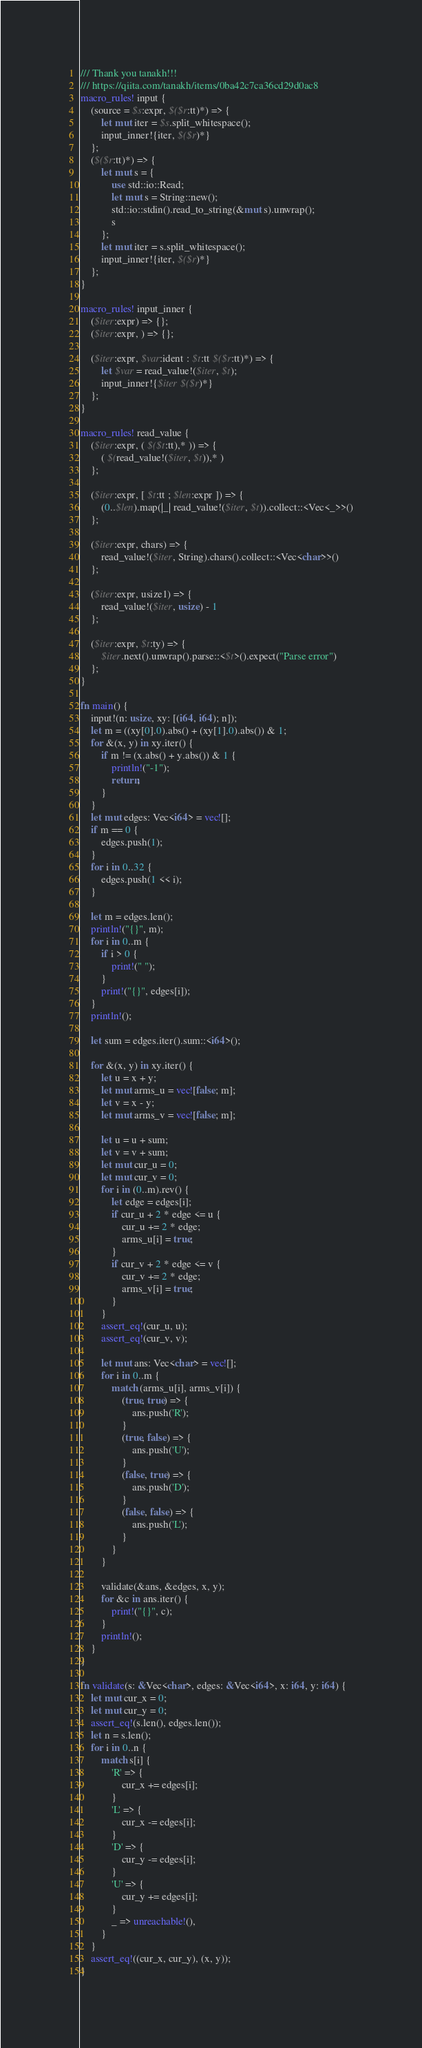<code> <loc_0><loc_0><loc_500><loc_500><_Rust_>/// Thank you tanakh!!!
/// https://qiita.com/tanakh/items/0ba42c7ca36cd29d0ac8
macro_rules! input {
    (source = $s:expr, $($r:tt)*) => {
        let mut iter = $s.split_whitespace();
        input_inner!{iter, $($r)*}
    };
    ($($r:tt)*) => {
        let mut s = {
            use std::io::Read;
            let mut s = String::new();
            std::io::stdin().read_to_string(&mut s).unwrap();
            s
        };
        let mut iter = s.split_whitespace();
        input_inner!{iter, $($r)*}
    };
}

macro_rules! input_inner {
    ($iter:expr) => {};
    ($iter:expr, ) => {};

    ($iter:expr, $var:ident : $t:tt $($r:tt)*) => {
        let $var = read_value!($iter, $t);
        input_inner!{$iter $($r)*}
    };
}

macro_rules! read_value {
    ($iter:expr, ( $($t:tt),* )) => {
        ( $(read_value!($iter, $t)),* )
    };

    ($iter:expr, [ $t:tt ; $len:expr ]) => {
        (0..$len).map(|_| read_value!($iter, $t)).collect::<Vec<_>>()
    };

    ($iter:expr, chars) => {
        read_value!($iter, String).chars().collect::<Vec<char>>()
    };

    ($iter:expr, usize1) => {
        read_value!($iter, usize) - 1
    };

    ($iter:expr, $t:ty) => {
        $iter.next().unwrap().parse::<$t>().expect("Parse error")
    };
}

fn main() {
    input!(n: usize, xy: [(i64, i64); n]);
    let m = ((xy[0].0).abs() + (xy[1].0).abs()) & 1;
    for &(x, y) in xy.iter() {
        if m != (x.abs() + y.abs()) & 1 {
            println!("-1");
            return;
        }
    }
    let mut edges: Vec<i64> = vec![];
    if m == 0 {
        edges.push(1);
    }
    for i in 0..32 {
        edges.push(1 << i);
    }

    let m = edges.len();
    println!("{}", m);
    for i in 0..m {
        if i > 0 {
            print!(" ");
        }
        print!("{}", edges[i]);
    }
    println!();

    let sum = edges.iter().sum::<i64>();

    for &(x, y) in xy.iter() {
        let u = x + y;
        let mut arms_u = vec![false; m];
        let v = x - y;
        let mut arms_v = vec![false; m];

        let u = u + sum;
        let v = v + sum;
        let mut cur_u = 0;
        let mut cur_v = 0;
        for i in (0..m).rev() {
            let edge = edges[i];
            if cur_u + 2 * edge <= u {
                cur_u += 2 * edge;
                arms_u[i] = true;
            }
            if cur_v + 2 * edge <= v {
                cur_v += 2 * edge;
                arms_v[i] = true;
            }
        }
        assert_eq!(cur_u, u);
        assert_eq!(cur_v, v);

        let mut ans: Vec<char> = vec![];
        for i in 0..m {
            match (arms_u[i], arms_v[i]) {
                (true, true) => {
                    ans.push('R');
                }
                (true, false) => {
                    ans.push('U');
                }
                (false, true) => {
                    ans.push('D');
                }
                (false, false) => {
                    ans.push('L');
                }
            }
        }

        validate(&ans, &edges, x, y);
        for &c in ans.iter() {
            print!("{}", c);
        }
        println!();
    }
}

fn validate(s: &Vec<char>, edges: &Vec<i64>, x: i64, y: i64) {
    let mut cur_x = 0;
    let mut cur_y = 0;
    assert_eq!(s.len(), edges.len());
    let n = s.len();
    for i in 0..n {
        match s[i] {
            'R' => {
                cur_x += edges[i];
            }
            'L' => {
                cur_x -= edges[i];
            }
            'D' => {
                cur_y -= edges[i];
            }
            'U' => {
                cur_y += edges[i];
            }
            _ => unreachable!(),
        }
    }
    assert_eq!((cur_x, cur_y), (x, y));
}
</code> 